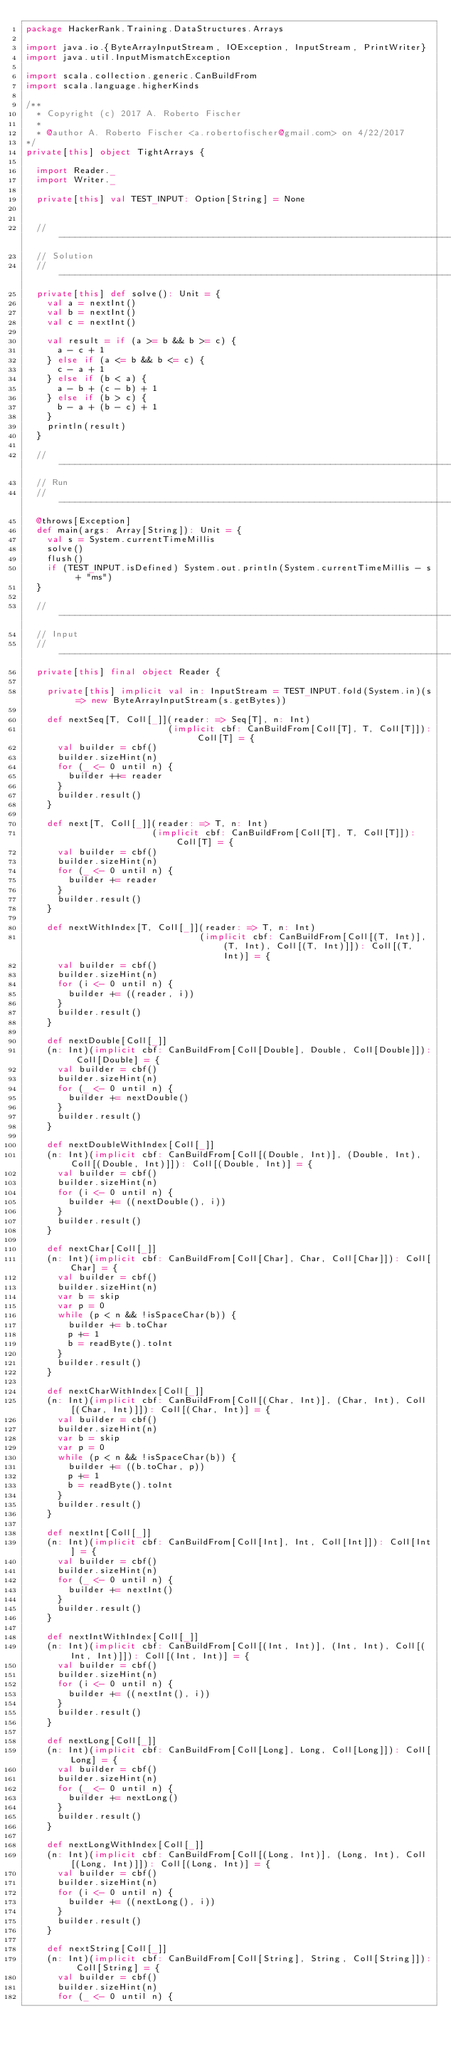<code> <loc_0><loc_0><loc_500><loc_500><_Scala_>package HackerRank.Training.DataStructures.Arrays

import java.io.{ByteArrayInputStream, IOException, InputStream, PrintWriter}
import java.util.InputMismatchException

import scala.collection.generic.CanBuildFrom
import scala.language.higherKinds

/**
  * Copyright (c) 2017 A. Roberto Fischer
  *
  * @author A. Roberto Fischer <a.robertofischer@gmail.com> on 4/22/2017
*/
private[this] object TightArrays {

  import Reader._
  import Writer._

  private[this] val TEST_INPUT: Option[String] = None


  //------------------------------------------------------------------------------------------//
  // Solution                                                                
  //------------------------------------------------------------------------------------------//
  private[this] def solve(): Unit = {
    val a = nextInt()
    val b = nextInt()
    val c = nextInt()

    val result = if (a >= b && b >= c) {
      a - c + 1
    } else if (a <= b && b <= c) {
      c - a + 1
    } else if (b < a) {
      a - b + (c - b) + 1
    } else if (b > c) {
      b - a + (b - c) + 1
    }
    println(result)
  }

  //------------------------------------------------------------------------------------------//
  // Run
  //------------------------------------------------------------------------------------------//
  @throws[Exception]
  def main(args: Array[String]): Unit = {
    val s = System.currentTimeMillis
    solve()
    flush()
    if (TEST_INPUT.isDefined) System.out.println(System.currentTimeMillis - s + "ms")
  }

  //------------------------------------------------------------------------------------------//
  // Input
  //------------------------------------------------------------------------------------------//
  private[this] final object Reader {

    private[this] implicit val in: InputStream = TEST_INPUT.fold(System.in)(s => new ByteArrayInputStream(s.getBytes))

    def nextSeq[T, Coll[_]](reader: => Seq[T], n: Int)
                           (implicit cbf: CanBuildFrom[Coll[T], T, Coll[T]]): Coll[T] = {
      val builder = cbf()
      builder.sizeHint(n)
      for (_ <- 0 until n) {
        builder ++= reader
      }
      builder.result()
    }

    def next[T, Coll[_]](reader: => T, n: Int)
                        (implicit cbf: CanBuildFrom[Coll[T], T, Coll[T]]): Coll[T] = {
      val builder = cbf()
      builder.sizeHint(n)
      for (_ <- 0 until n) {
        builder += reader
      }
      builder.result()
    }

    def nextWithIndex[T, Coll[_]](reader: => T, n: Int)
                                 (implicit cbf: CanBuildFrom[Coll[(T, Int)], (T, Int), Coll[(T, Int)]]): Coll[(T, Int)] = {
      val builder = cbf()
      builder.sizeHint(n)
      for (i <- 0 until n) {
        builder += ((reader, i))
      }
      builder.result()
    }

    def nextDouble[Coll[_]]
    (n: Int)(implicit cbf: CanBuildFrom[Coll[Double], Double, Coll[Double]]): Coll[Double] = {
      val builder = cbf()
      builder.sizeHint(n)
      for (_ <- 0 until n) {
        builder += nextDouble()
      }
      builder.result()
    }

    def nextDoubleWithIndex[Coll[_]]
    (n: Int)(implicit cbf: CanBuildFrom[Coll[(Double, Int)], (Double, Int), Coll[(Double, Int)]]): Coll[(Double, Int)] = {
      val builder = cbf()
      builder.sizeHint(n)
      for (i <- 0 until n) {
        builder += ((nextDouble(), i))
      }
      builder.result()
    }

    def nextChar[Coll[_]]
    (n: Int)(implicit cbf: CanBuildFrom[Coll[Char], Char, Coll[Char]]): Coll[Char] = {
      val builder = cbf()
      builder.sizeHint(n)
      var b = skip
      var p = 0
      while (p < n && !isSpaceChar(b)) {
        builder += b.toChar
        p += 1
        b = readByte().toInt
      }
      builder.result()
    }

    def nextCharWithIndex[Coll[_]]
    (n: Int)(implicit cbf: CanBuildFrom[Coll[(Char, Int)], (Char, Int), Coll[(Char, Int)]]): Coll[(Char, Int)] = {
      val builder = cbf()
      builder.sizeHint(n)
      var b = skip
      var p = 0
      while (p < n && !isSpaceChar(b)) {
        builder += ((b.toChar, p))
        p += 1
        b = readByte().toInt
      }
      builder.result()
    }

    def nextInt[Coll[_]]
    (n: Int)(implicit cbf: CanBuildFrom[Coll[Int], Int, Coll[Int]]): Coll[Int] = {
      val builder = cbf()
      builder.sizeHint(n)
      for (_ <- 0 until n) {
        builder += nextInt()
      }
      builder.result()
    }

    def nextIntWithIndex[Coll[_]]
    (n: Int)(implicit cbf: CanBuildFrom[Coll[(Int, Int)], (Int, Int), Coll[(Int, Int)]]): Coll[(Int, Int)] = {
      val builder = cbf()
      builder.sizeHint(n)
      for (i <- 0 until n) {
        builder += ((nextInt(), i))
      }
      builder.result()
    }

    def nextLong[Coll[_]]
    (n: Int)(implicit cbf: CanBuildFrom[Coll[Long], Long, Coll[Long]]): Coll[Long] = {
      val builder = cbf()
      builder.sizeHint(n)
      for (_ <- 0 until n) {
        builder += nextLong()
      }
      builder.result()
    }

    def nextLongWithIndex[Coll[_]]
    (n: Int)(implicit cbf: CanBuildFrom[Coll[(Long, Int)], (Long, Int), Coll[(Long, Int)]]): Coll[(Long, Int)] = {
      val builder = cbf()
      builder.sizeHint(n)
      for (i <- 0 until n) {
        builder += ((nextLong(), i))
      }
      builder.result()
    }

    def nextString[Coll[_]]
    (n: Int)(implicit cbf: CanBuildFrom[Coll[String], String, Coll[String]]): Coll[String] = {
      val builder = cbf()
      builder.sizeHint(n)
      for (_ <- 0 until n) {</code> 